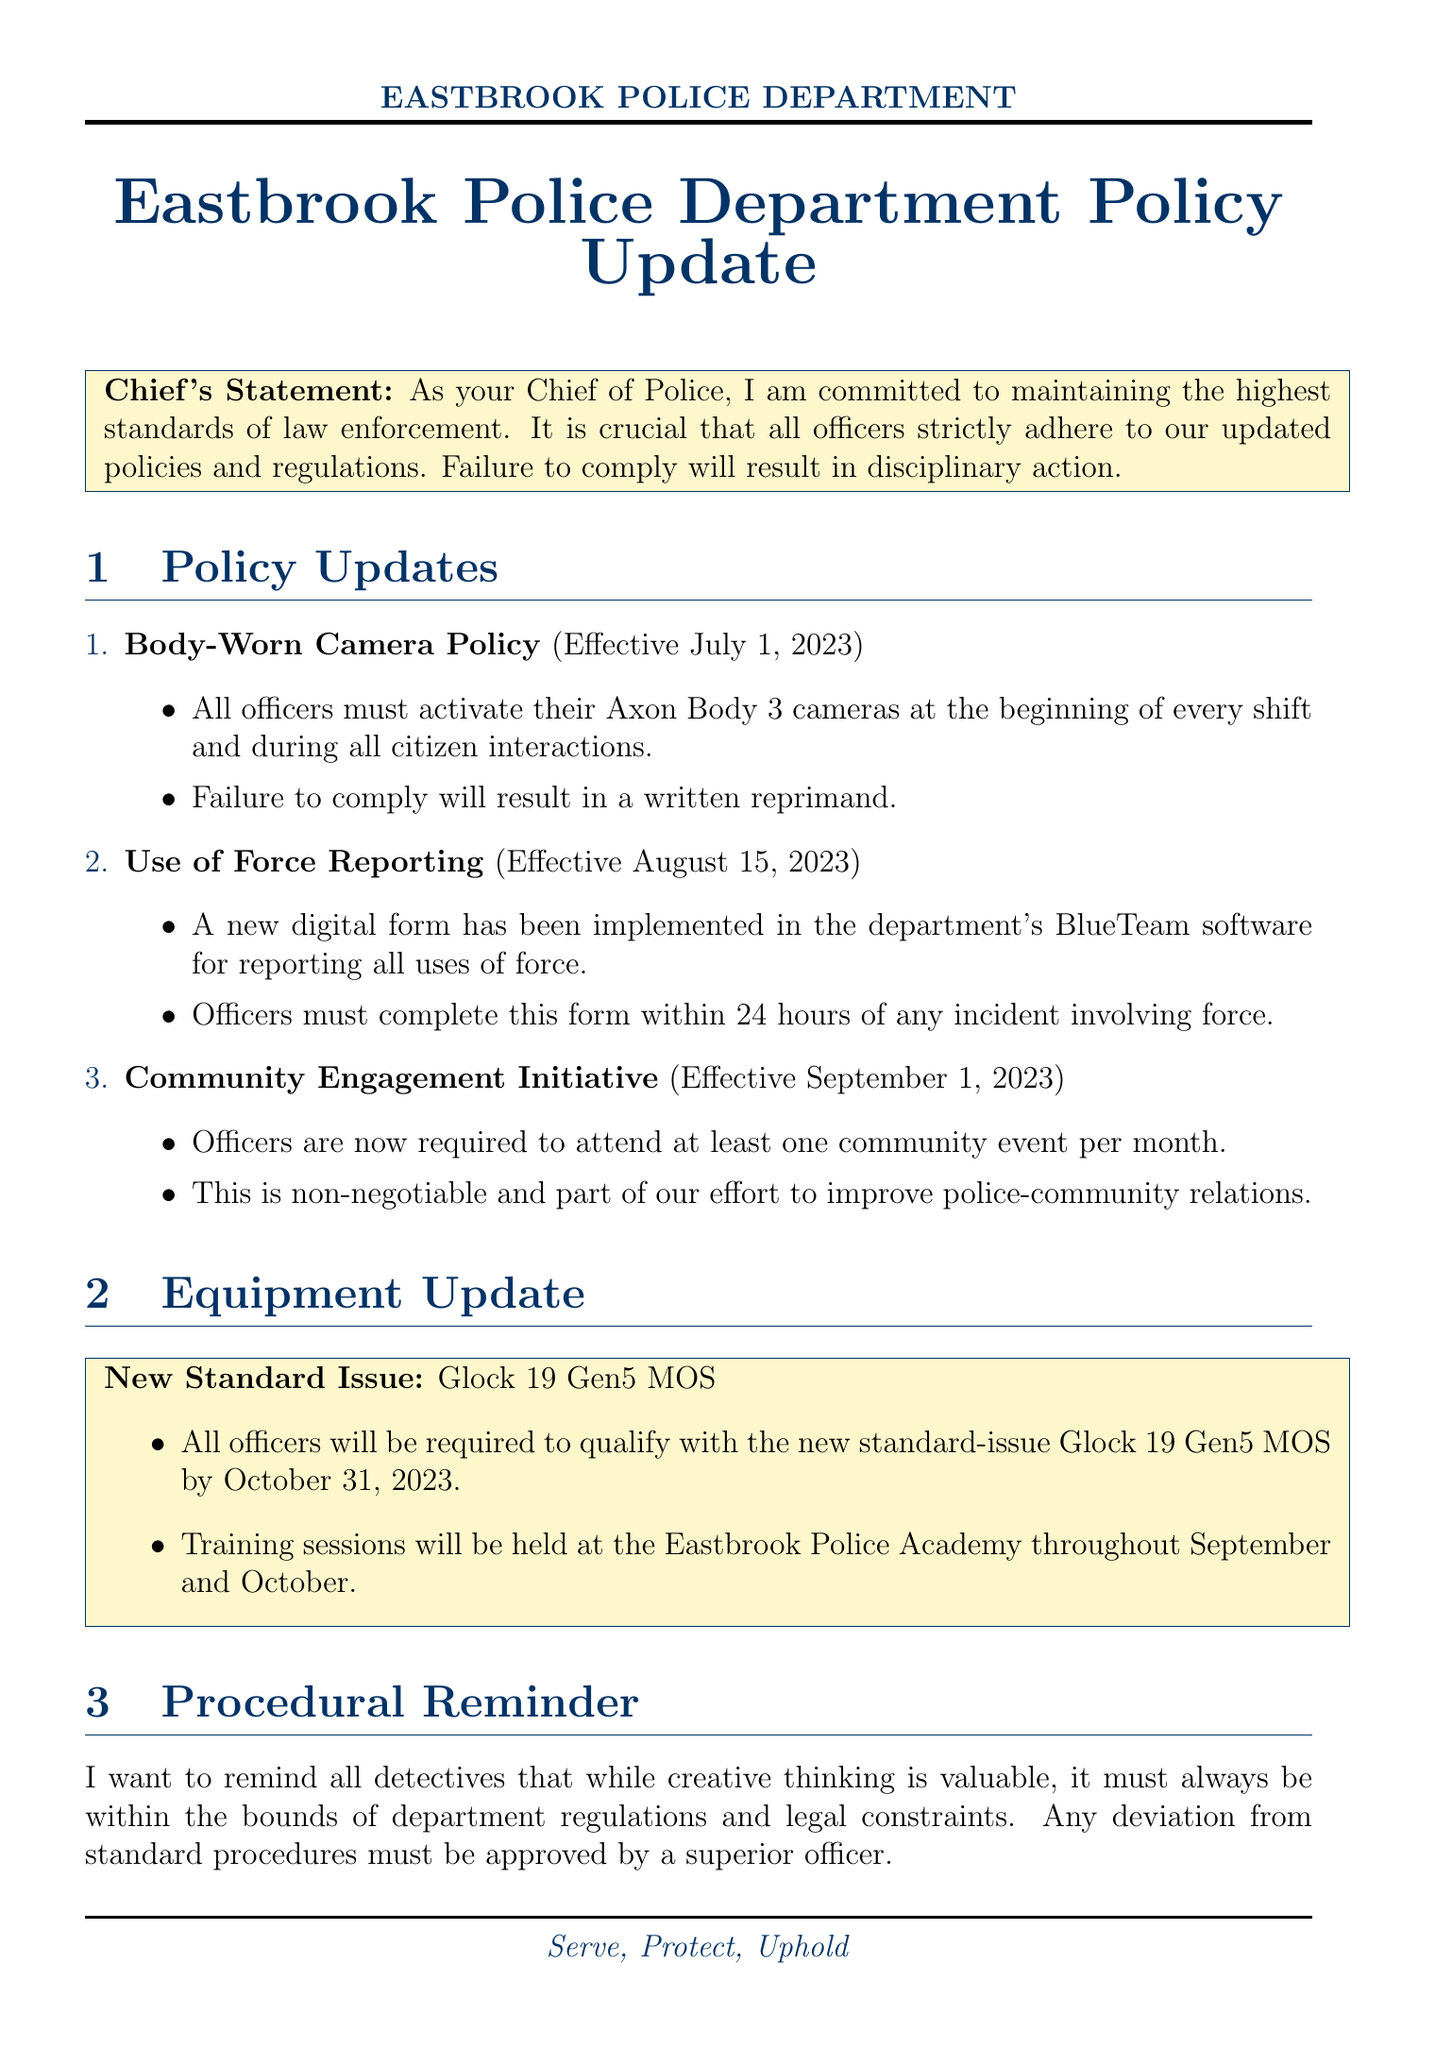When must body-worn cameras be activated? The document explicitly states that body-worn cameras must be activated at the beginning of every shift and during all citizen interactions.
Answer: At the beginning of every shift and during all citizen interactions What is the implementation date for the Use of Force Reporting policy? The implementation date for the Use of Force Reporting policy is clearly mentioned in the document.
Answer: August 15, 2023 How many community events are officers required to attend per month? The document specifies that officers are required to attend at least one community event per month as part of the new initiative.
Answer: One By what date must all officers qualify with the new Glock 19 Gen5 MOS? The document states the deadline for qualifying with the new standard-issue Glock 19 Gen5 MOS.
Answer: October 31, 2023 What consequence is stated for failing to activate body-worn cameras? According to the document, failing to activate body-worn cameras will lead to disciplinary action, specifically a written reprimand.
Answer: Written reprimand What is the purpose of the Community Engagement Initiative? The purpose of the Community Engagement Initiative is to improve police-community relations, as outlined in the policy update.
Answer: Improve police-community relations What software is used for the new digital form for reporting uses of force? The document specifies that the new digital form is implemented in the BlueTeam software for reporting uses of force.
Answer: BlueTeam What must be approved by a superior officer according to the procedural reminder? The procedural reminder indicates that any deviation from standard procedures must receive approval from a superior officer.
Answer: Deviation from standard procedures 